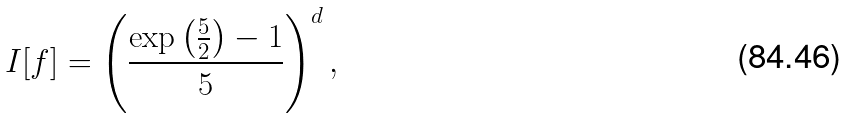Convert formula to latex. <formula><loc_0><loc_0><loc_500><loc_500>I [ f ] = \left ( \frac { \exp \left ( \frac { 5 } { 2 } \right ) - 1 } { 5 } \right ) ^ { d } ,</formula> 